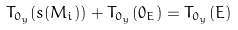Convert formula to latex. <formula><loc_0><loc_0><loc_500><loc_500>T _ { 0 _ { y } } ( s ( M _ { i } ) ) + T _ { 0 _ { y } } ( 0 _ { E } ) = T _ { 0 _ { y } } ( E )</formula> 